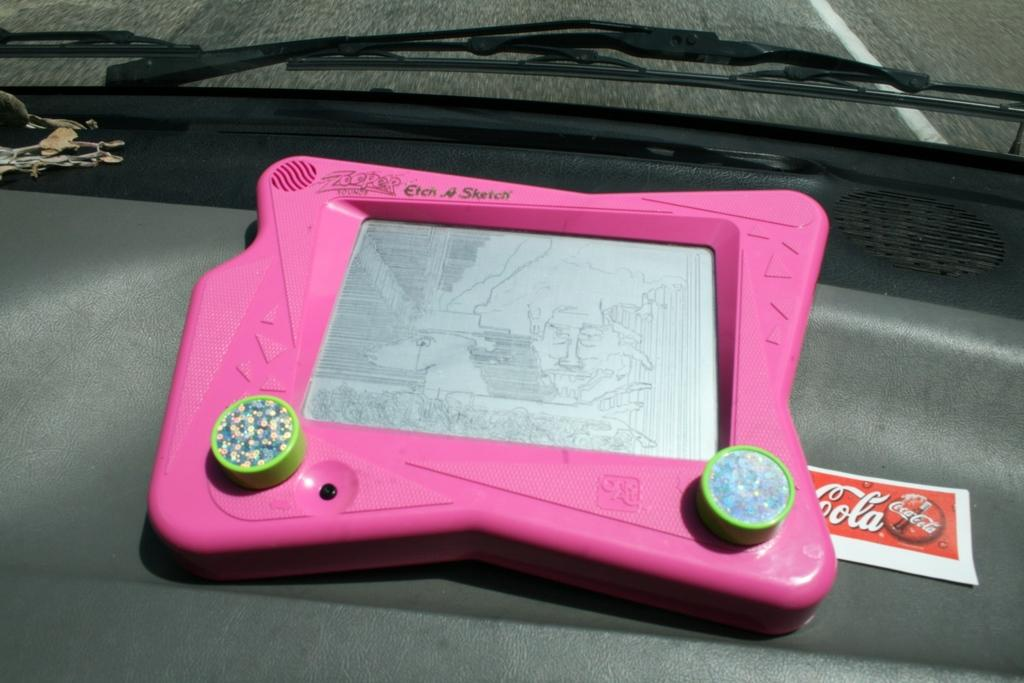What is the main object in the image? There is a game board in the image. Are there any other objects related to the game? Yes, there is a card in the image. Where are the game board and card located? The objects are inside a vehicle. What can be seen through the glass of the vehicle? The road is visible through the glass of the vehicle. How many geese are standing on the game board in the image? There are no geese present on the game board in the image. What type of legs can be seen on the card in the image? There are no legs visible on the card in the image. 